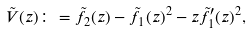<formula> <loc_0><loc_0><loc_500><loc_500>\tilde { V } ( z ) \colon = \tilde { f } _ { 2 } ( z ) - \tilde { f } _ { 1 } ( z ) ^ { 2 } - z \tilde { f } _ { 1 } ^ { \prime } ( z ) ^ { 2 } ,</formula> 